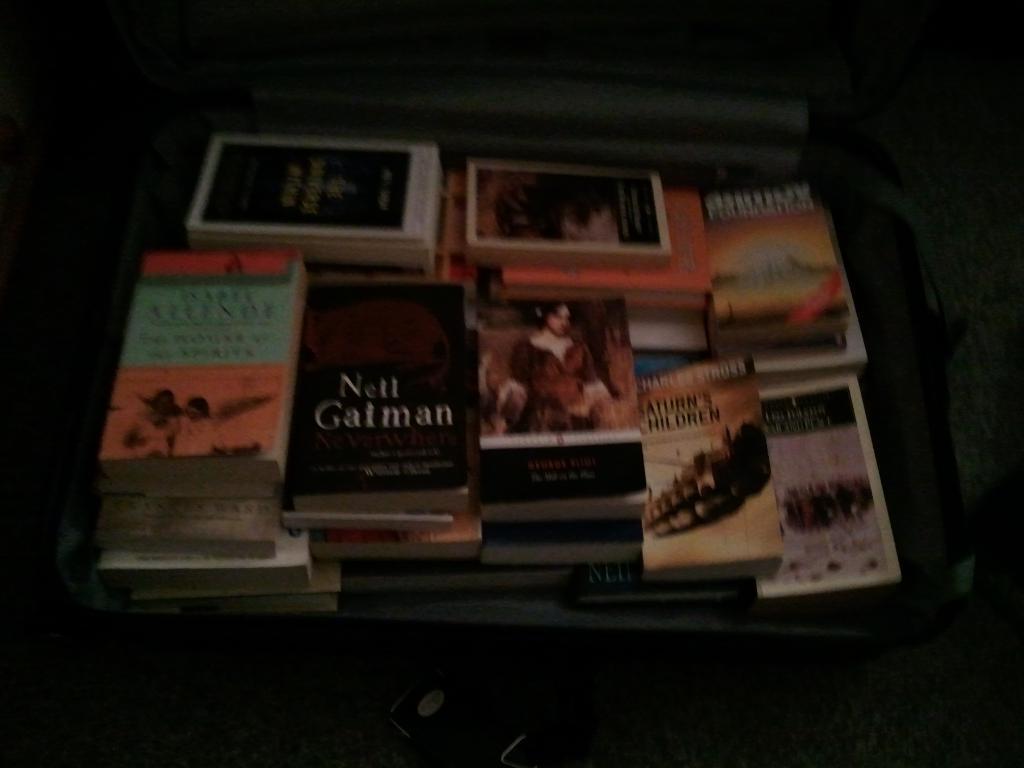Could you give a brief overview of what you see in this image? In this picture we can see books in a suitcase and this suitcase is placed on a platform and in the background it is dark. 